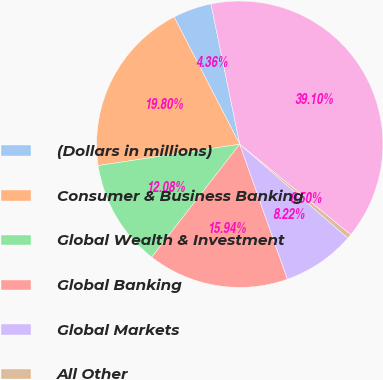Convert chart to OTSL. <chart><loc_0><loc_0><loc_500><loc_500><pie_chart><fcel>(Dollars in millions)<fcel>Consumer & Business Banking<fcel>Global Wealth & Investment<fcel>Global Banking<fcel>Global Markets<fcel>All Other<fcel>Total goodwill<nl><fcel>4.36%<fcel>19.8%<fcel>12.08%<fcel>15.94%<fcel>8.22%<fcel>0.5%<fcel>39.1%<nl></chart> 